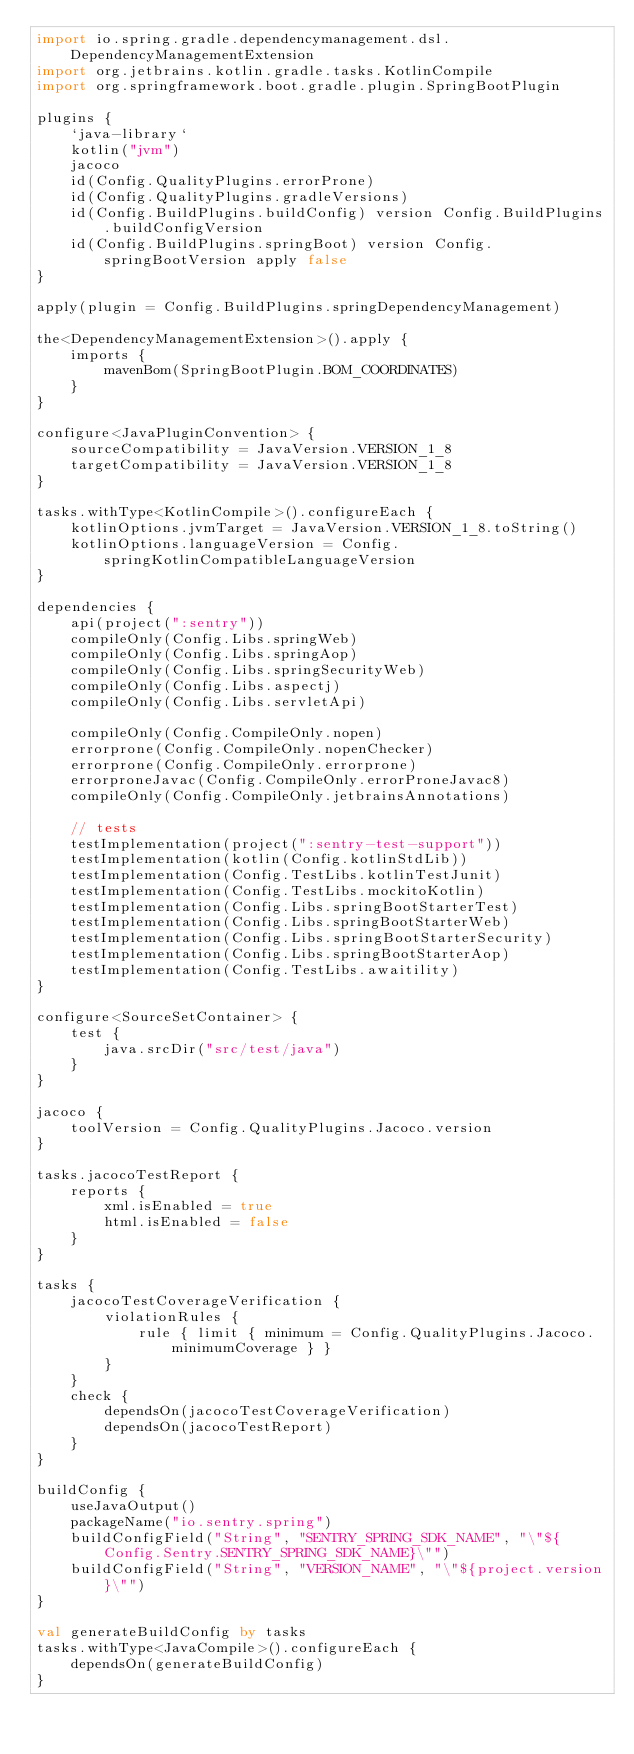Convert code to text. <code><loc_0><loc_0><loc_500><loc_500><_Kotlin_>import io.spring.gradle.dependencymanagement.dsl.DependencyManagementExtension
import org.jetbrains.kotlin.gradle.tasks.KotlinCompile
import org.springframework.boot.gradle.plugin.SpringBootPlugin

plugins {
    `java-library`
    kotlin("jvm")
    jacoco
    id(Config.QualityPlugins.errorProne)
    id(Config.QualityPlugins.gradleVersions)
    id(Config.BuildPlugins.buildConfig) version Config.BuildPlugins.buildConfigVersion
    id(Config.BuildPlugins.springBoot) version Config.springBootVersion apply false
}

apply(plugin = Config.BuildPlugins.springDependencyManagement)

the<DependencyManagementExtension>().apply {
    imports {
        mavenBom(SpringBootPlugin.BOM_COORDINATES)
    }
}

configure<JavaPluginConvention> {
    sourceCompatibility = JavaVersion.VERSION_1_8
    targetCompatibility = JavaVersion.VERSION_1_8
}

tasks.withType<KotlinCompile>().configureEach {
    kotlinOptions.jvmTarget = JavaVersion.VERSION_1_8.toString()
    kotlinOptions.languageVersion = Config.springKotlinCompatibleLanguageVersion
}

dependencies {
    api(project(":sentry"))
    compileOnly(Config.Libs.springWeb)
    compileOnly(Config.Libs.springAop)
    compileOnly(Config.Libs.springSecurityWeb)
    compileOnly(Config.Libs.aspectj)
    compileOnly(Config.Libs.servletApi)

    compileOnly(Config.CompileOnly.nopen)
    errorprone(Config.CompileOnly.nopenChecker)
    errorprone(Config.CompileOnly.errorprone)
    errorproneJavac(Config.CompileOnly.errorProneJavac8)
    compileOnly(Config.CompileOnly.jetbrainsAnnotations)

    // tests
    testImplementation(project(":sentry-test-support"))
    testImplementation(kotlin(Config.kotlinStdLib))
    testImplementation(Config.TestLibs.kotlinTestJunit)
    testImplementation(Config.TestLibs.mockitoKotlin)
    testImplementation(Config.Libs.springBootStarterTest)
    testImplementation(Config.Libs.springBootStarterWeb)
    testImplementation(Config.Libs.springBootStarterSecurity)
    testImplementation(Config.Libs.springBootStarterAop)
    testImplementation(Config.TestLibs.awaitility)
}

configure<SourceSetContainer> {
    test {
        java.srcDir("src/test/java")
    }
}

jacoco {
    toolVersion = Config.QualityPlugins.Jacoco.version
}

tasks.jacocoTestReport {
    reports {
        xml.isEnabled = true
        html.isEnabled = false
    }
}

tasks {
    jacocoTestCoverageVerification {
        violationRules {
            rule { limit { minimum = Config.QualityPlugins.Jacoco.minimumCoverage } }
        }
    }
    check {
        dependsOn(jacocoTestCoverageVerification)
        dependsOn(jacocoTestReport)
    }
}

buildConfig {
    useJavaOutput()
    packageName("io.sentry.spring")
    buildConfigField("String", "SENTRY_SPRING_SDK_NAME", "\"${Config.Sentry.SENTRY_SPRING_SDK_NAME}\"")
    buildConfigField("String", "VERSION_NAME", "\"${project.version}\"")
}

val generateBuildConfig by tasks
tasks.withType<JavaCompile>().configureEach {
    dependsOn(generateBuildConfig)
}
</code> 